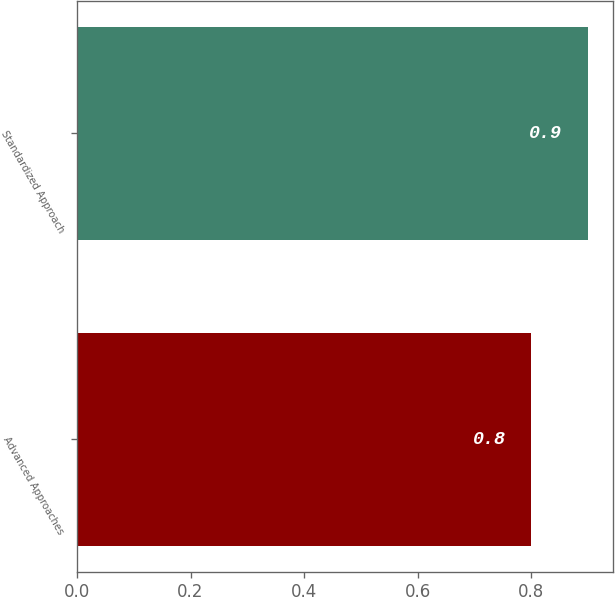<chart> <loc_0><loc_0><loc_500><loc_500><bar_chart><fcel>Advanced Approaches<fcel>Standardized Approach<nl><fcel>0.8<fcel>0.9<nl></chart> 